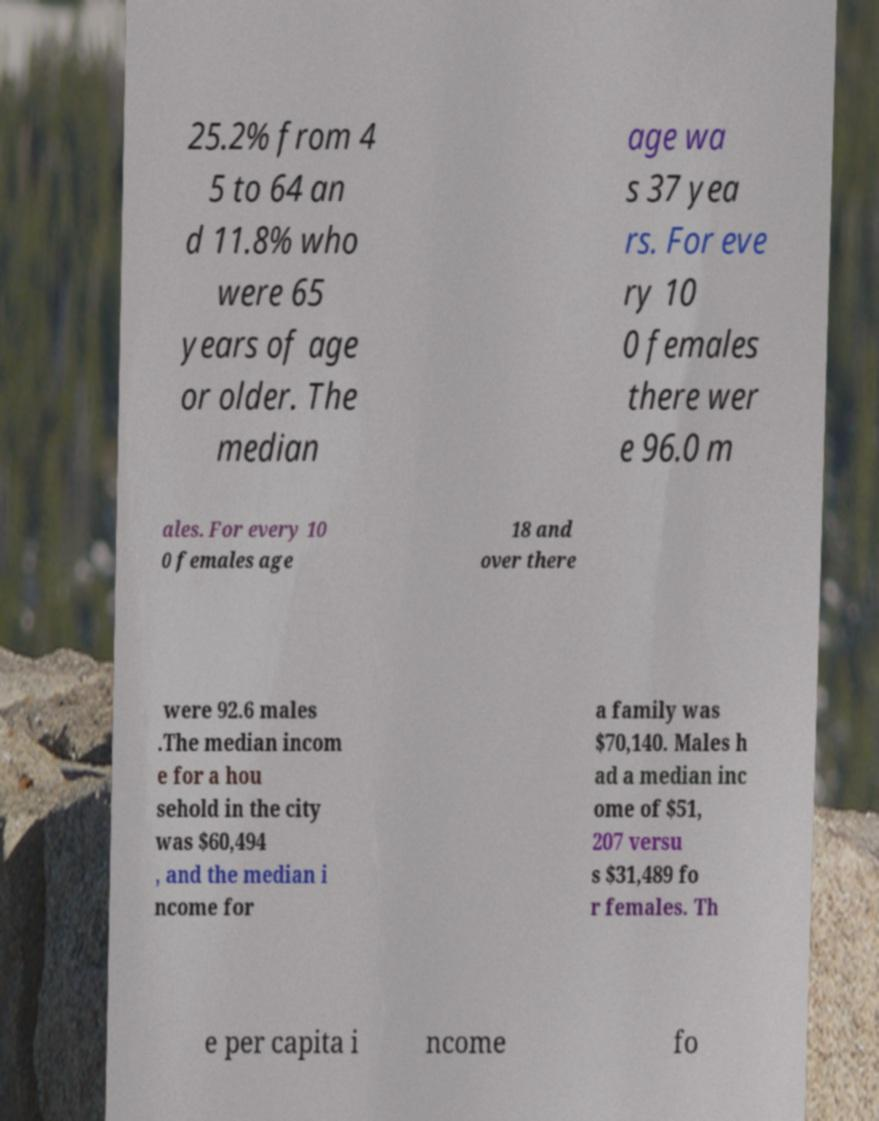Could you extract and type out the text from this image? 25.2% from 4 5 to 64 an d 11.8% who were 65 years of age or older. The median age wa s 37 yea rs. For eve ry 10 0 females there wer e 96.0 m ales. For every 10 0 females age 18 and over there were 92.6 males .The median incom e for a hou sehold in the city was $60,494 , and the median i ncome for a family was $70,140. Males h ad a median inc ome of $51, 207 versu s $31,489 fo r females. Th e per capita i ncome fo 